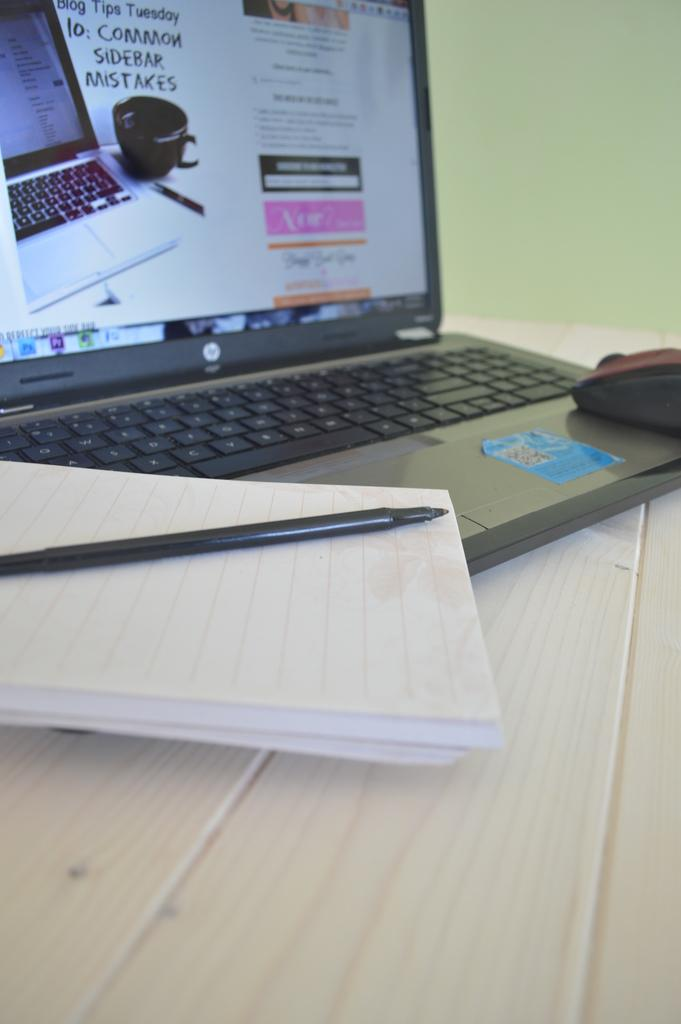What piece of furniture is visible in the image? There is a table in the image. What electronic device is placed on the table? A laptop is placed on the table. What type of reading material is on the table? There is a book on the table. What writing instrument is present on the table? A pen is present on the table. What accessory is likely used for computer interaction on the table? A mouse (likely a computer mouse) is on the table. What can be seen in the background of the image? There is a wall in the background of the image. What type of bird can be seen flying near the wall in the image? There is no bird present in the image; it only features a table with various objects and a wall in the background. What type of treatment is being administered to the laptop in the image? There is no treatment being administered to the laptop in the image; it is simply placed on the table. 